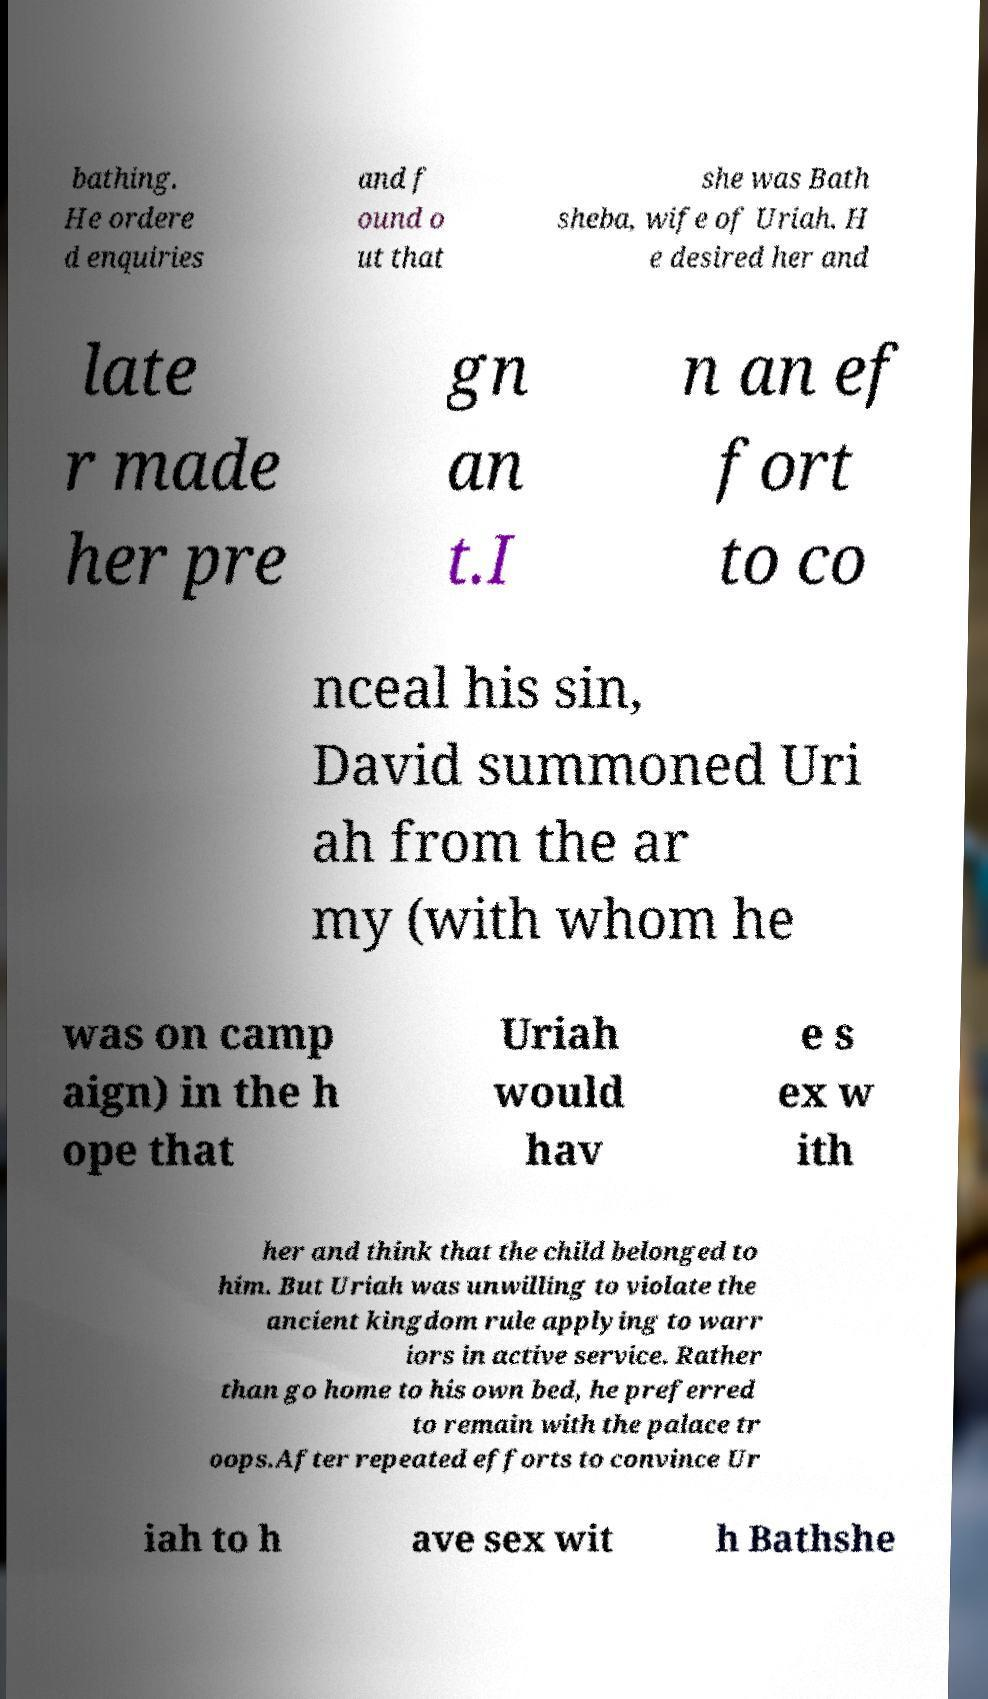What messages or text are displayed in this image? I need them in a readable, typed format. bathing. He ordere d enquiries and f ound o ut that she was Bath sheba, wife of Uriah. H e desired her and late r made her pre gn an t.I n an ef fort to co nceal his sin, David summoned Uri ah from the ar my (with whom he was on camp aign) in the h ope that Uriah would hav e s ex w ith her and think that the child belonged to him. But Uriah was unwilling to violate the ancient kingdom rule applying to warr iors in active service. Rather than go home to his own bed, he preferred to remain with the palace tr oops.After repeated efforts to convince Ur iah to h ave sex wit h Bathshe 